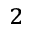Convert formula to latex. <formula><loc_0><loc_0><loc_500><loc_500>^ { 2 }</formula> 